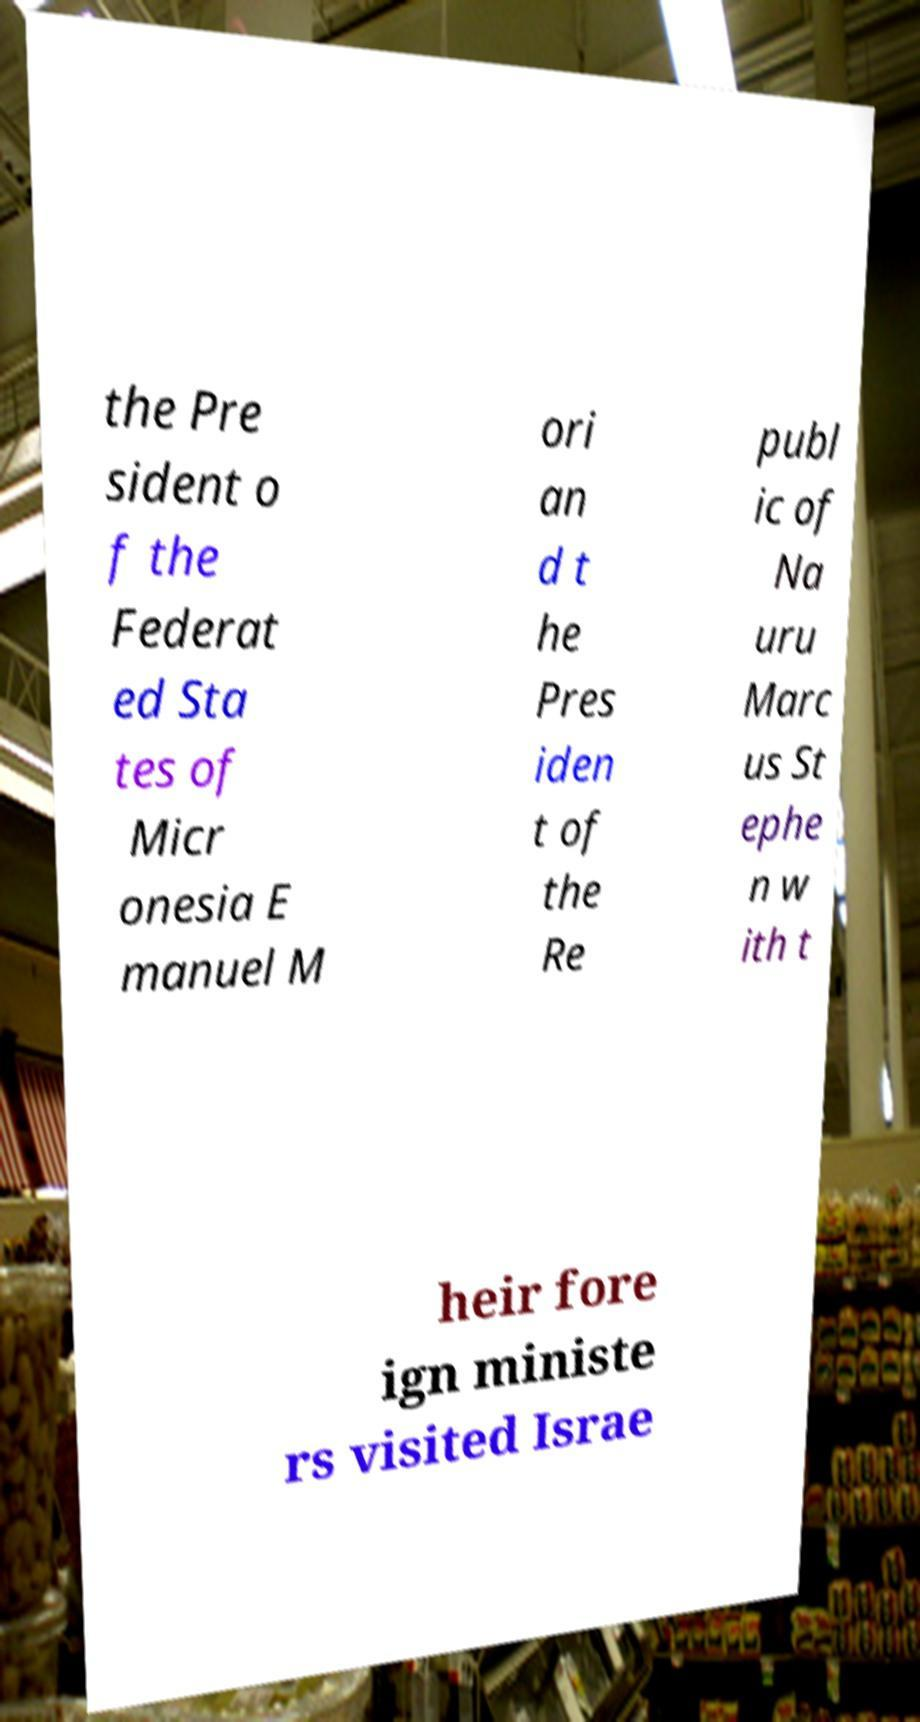There's text embedded in this image that I need extracted. Can you transcribe it verbatim? the Pre sident o f the Federat ed Sta tes of Micr onesia E manuel M ori an d t he Pres iden t of the Re publ ic of Na uru Marc us St ephe n w ith t heir fore ign ministe rs visited Israe 